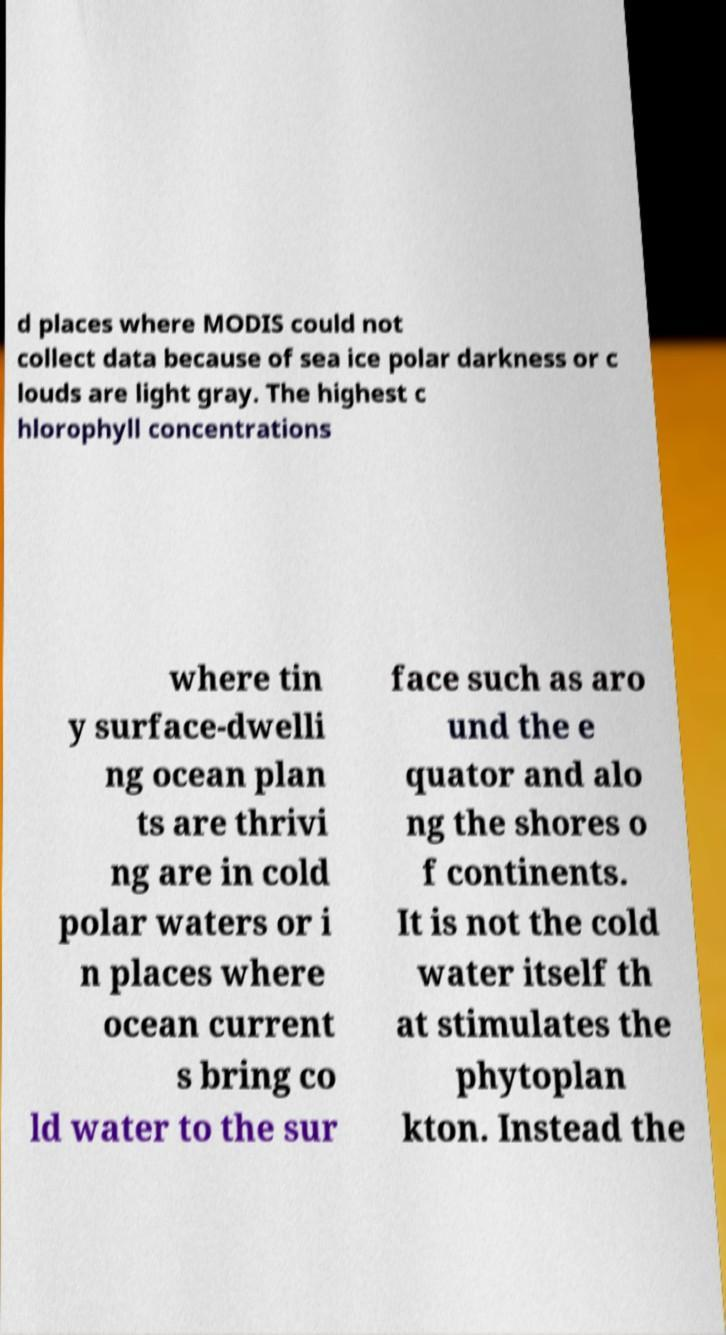I need the written content from this picture converted into text. Can you do that? d places where MODIS could not collect data because of sea ice polar darkness or c louds are light gray. The highest c hlorophyll concentrations where tin y surface-dwelli ng ocean plan ts are thrivi ng are in cold polar waters or i n places where ocean current s bring co ld water to the sur face such as aro und the e quator and alo ng the shores o f continents. It is not the cold water itself th at stimulates the phytoplan kton. Instead the 